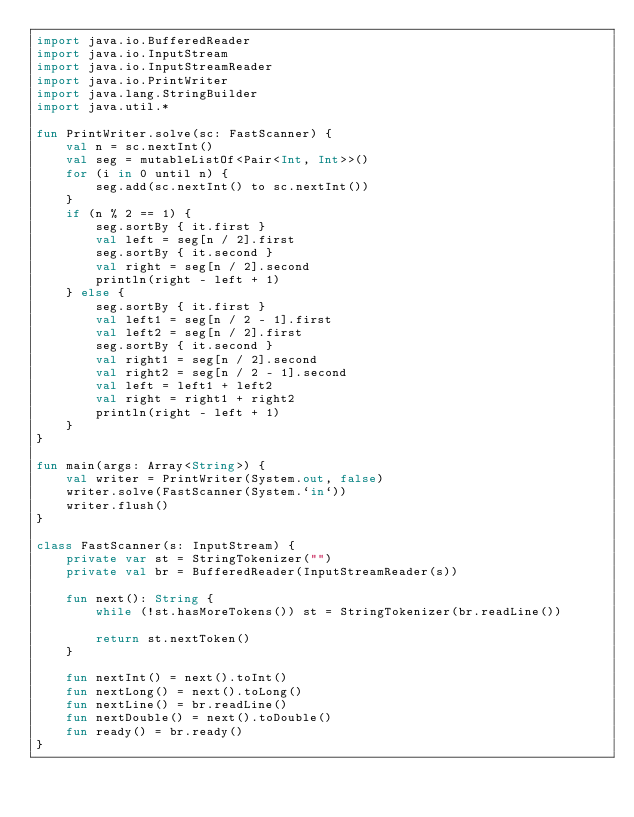<code> <loc_0><loc_0><loc_500><loc_500><_Kotlin_>import java.io.BufferedReader
import java.io.InputStream
import java.io.InputStreamReader
import java.io.PrintWriter
import java.lang.StringBuilder
import java.util.*

fun PrintWriter.solve(sc: FastScanner) {
    val n = sc.nextInt()
    val seg = mutableListOf<Pair<Int, Int>>()
    for (i in 0 until n) {
        seg.add(sc.nextInt() to sc.nextInt())
    }
    if (n % 2 == 1) {
        seg.sortBy { it.first }
        val left = seg[n / 2].first
        seg.sortBy { it.second }
        val right = seg[n / 2].second
        println(right - left + 1)
    } else {
        seg.sortBy { it.first }
        val left1 = seg[n / 2 - 1].first
        val left2 = seg[n / 2].first
        seg.sortBy { it.second }
        val right1 = seg[n / 2].second
        val right2 = seg[n / 2 - 1].second
        val left = left1 + left2
        val right = right1 + right2
        println(right - left + 1)
    }
}

fun main(args: Array<String>) {
    val writer = PrintWriter(System.out, false)
    writer.solve(FastScanner(System.`in`))
    writer.flush()
}

class FastScanner(s: InputStream) {
    private var st = StringTokenizer("")
    private val br = BufferedReader(InputStreamReader(s))

    fun next(): String {
        while (!st.hasMoreTokens()) st = StringTokenizer(br.readLine())

        return st.nextToken()
    }

    fun nextInt() = next().toInt()
    fun nextLong() = next().toLong()
    fun nextLine() = br.readLine()
    fun nextDouble() = next().toDouble()
    fun ready() = br.ready()
}
</code> 